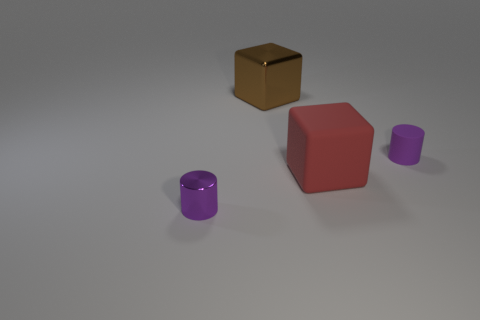The metallic thing that is behind the small purple cylinder that is to the left of the purple rubber object is what color? The metallic object behind the small purple cylinder, which is located to the left of the purple rubber object, appears to be a golden color that reflects light, suggesting a polished, shiny surface. 